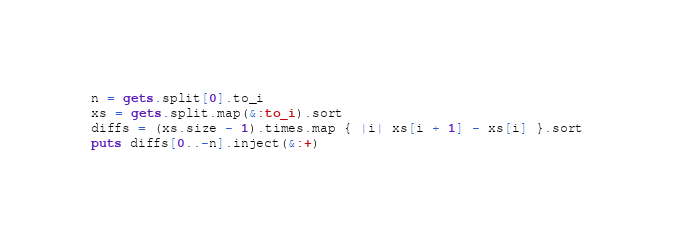<code> <loc_0><loc_0><loc_500><loc_500><_Ruby_>n = gets.split[0].to_i
xs = gets.split.map(&:to_i).sort
diffs = (xs.size - 1).times.map { |i| xs[i + 1] - xs[i] }.sort
puts diffs[0..-n].inject(&:+)
</code> 